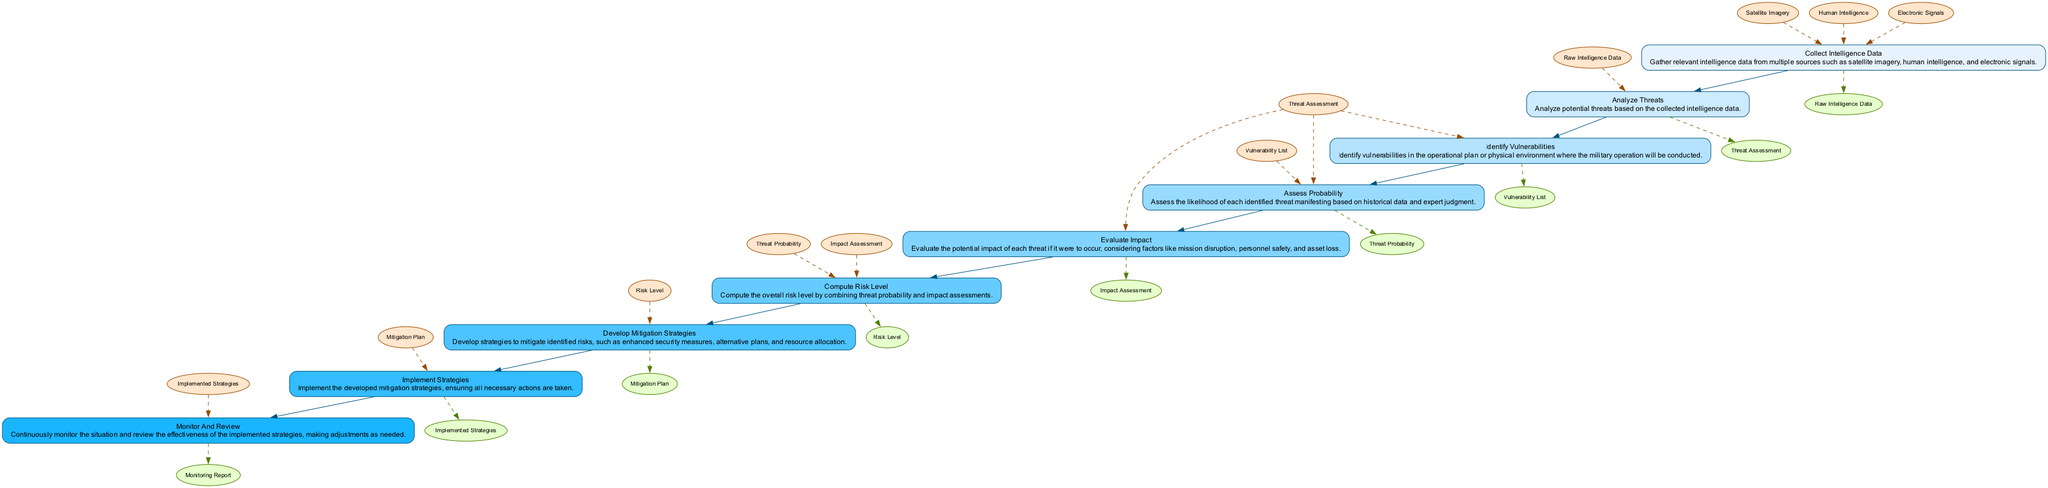What is the first step in the operational risk assessment process? The first step is "collect intelligence data," where relevant intelligence data is gathered to initiate the process.
Answer: collect intelligence data How many elements are there in the flowchart? There are eight distinct elements that represent steps in the operational risk assessment process, each contributing to the overall assessment.
Answer: eight What is the output of the "analyze threats" node? The output of the "analyze threats" node is "threat assessment," which is derived from analyzing the collected intelligence data.
Answer: threat assessment Which two nodes are directly connected by an edge? There are many direct connections; one example is the edge between "evaluate impact" and "compute risk level," indicating a sequential dependency.
Answer: evaluate impact and compute risk level What is the input for the "develop mitigation strategies" step? The input required for "develop mitigation strategies" is the "risk level," which combines previous assessments to guide strategy formulation.
Answer: risk level If the "analyze threats" step outputs a "threat assessment," which step comes next? Following the "analyze threats" step, the "identify vulnerabilities" step takes the "threat assessment" as input to determine the vulnerabilities present.
Answer: identify vulnerabilities How does "monitor and review" relate to "implement strategies"? The "monitor and review" step is based on the "implemented strategies" to assess their effectiveness, showing a feedback loop in the risk management process.
Answer: feedback loop Which step directly utilizes both threat assessment and vulnerability list? The "assess probability" step utilizes both the "threat assessment" and "vulnerability list" to evaluate the likelihood of threats occurring.
Answer: assess probability What color represents the nodes in the flowchart? The nodes are color-coded, with a specific color scheme that varies—each node's color differs based on its position, with light shades for steps and darker hues for inputs/outputs.
Answer: light shades 